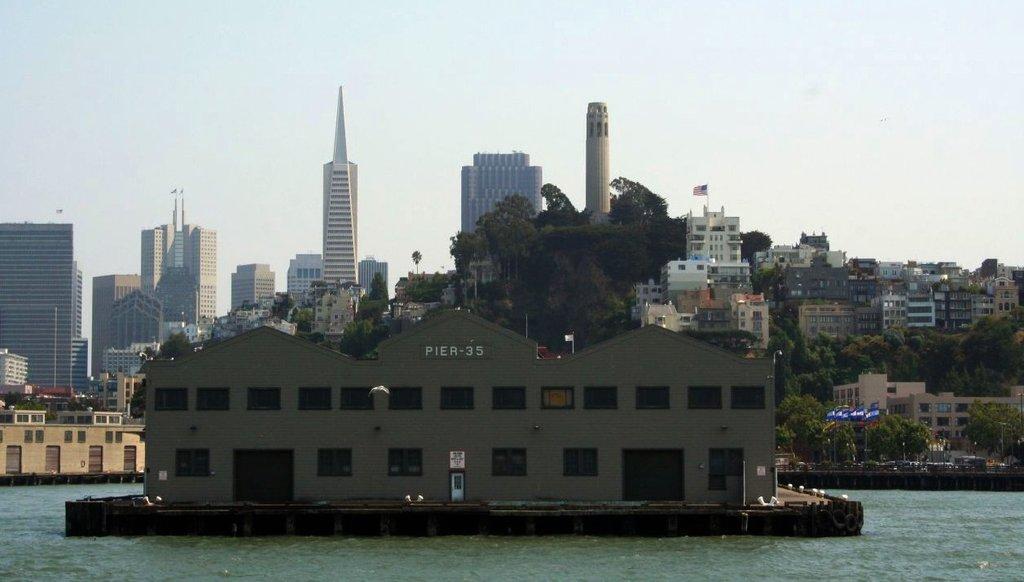Please provide a concise description of this image. In this image we can see buildings, trees, flags to the flag posts, towers and sky in the background. At the bottom of the image we can see water. 